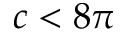<formula> <loc_0><loc_0><loc_500><loc_500>c < 8 \pi</formula> 